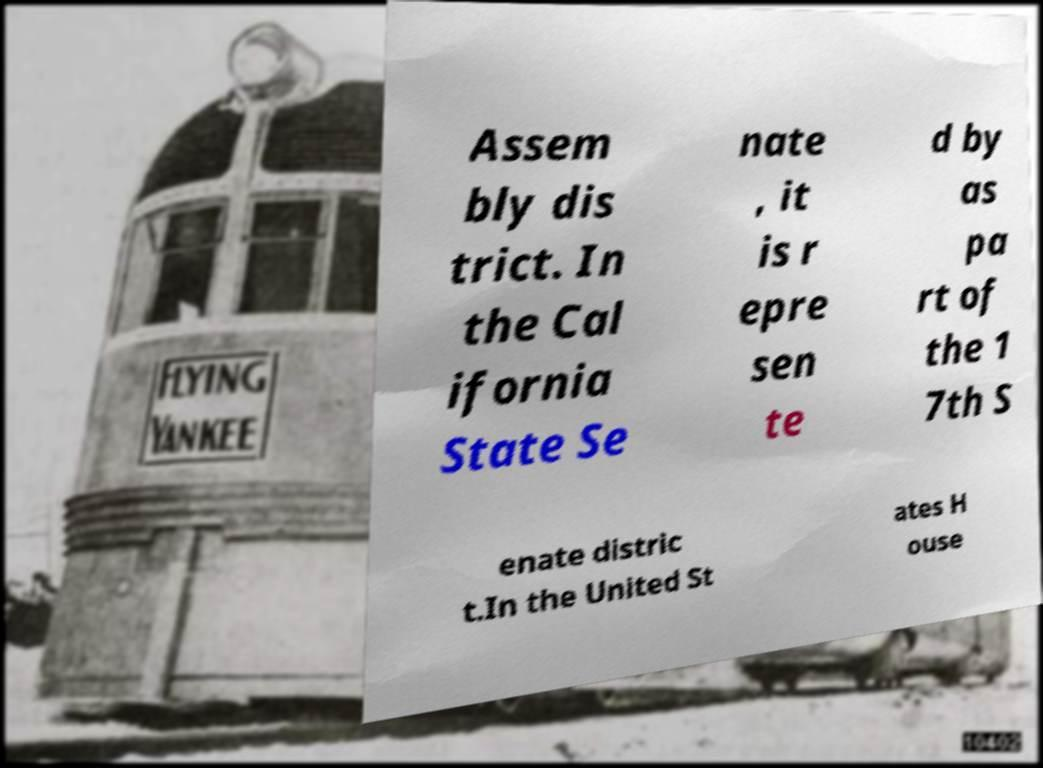There's text embedded in this image that I need extracted. Can you transcribe it verbatim? Assem bly dis trict. In the Cal ifornia State Se nate , it is r epre sen te d by as pa rt of the 1 7th S enate distric t.In the United St ates H ouse 